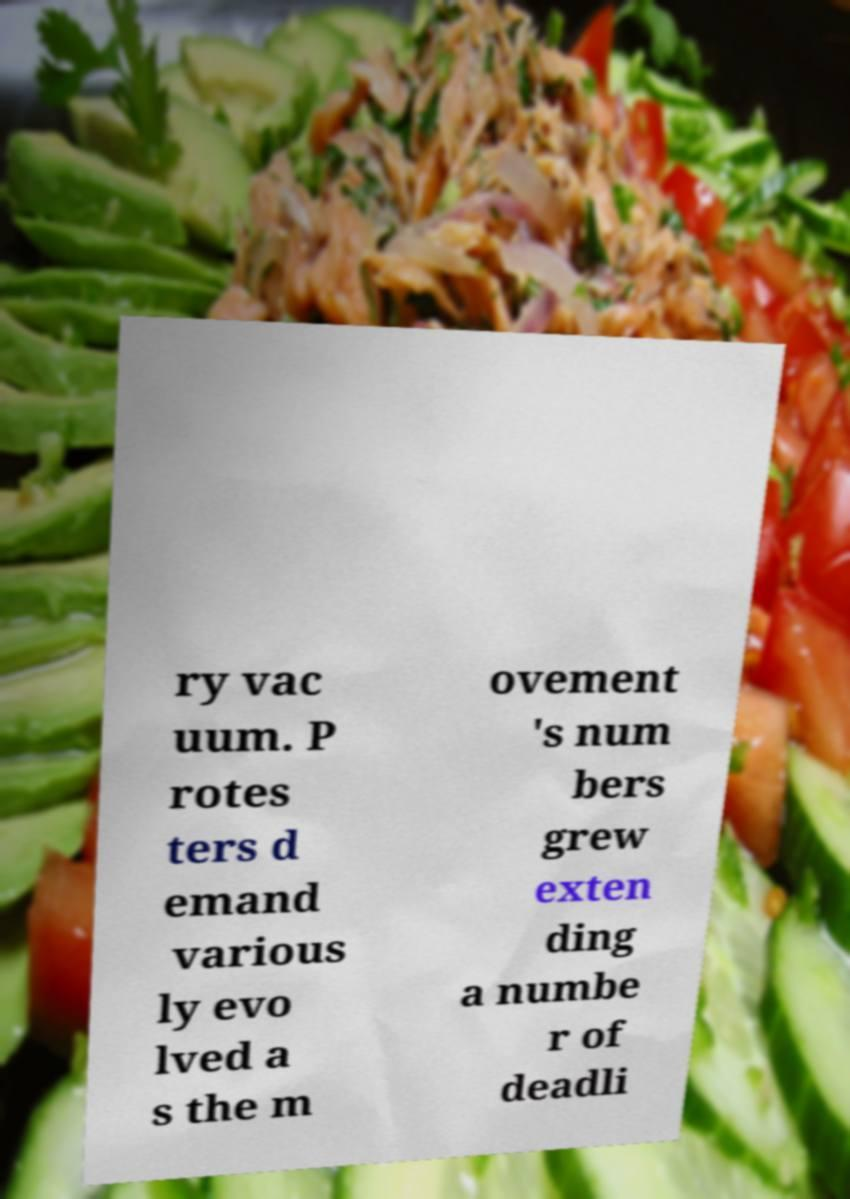What messages or text are displayed in this image? I need them in a readable, typed format. ry vac uum. P rotes ters d emand various ly evo lved a s the m ovement 's num bers grew exten ding a numbe r of deadli 